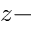Convert formula to latex. <formula><loc_0><loc_0><loc_500><loc_500>z -</formula> 